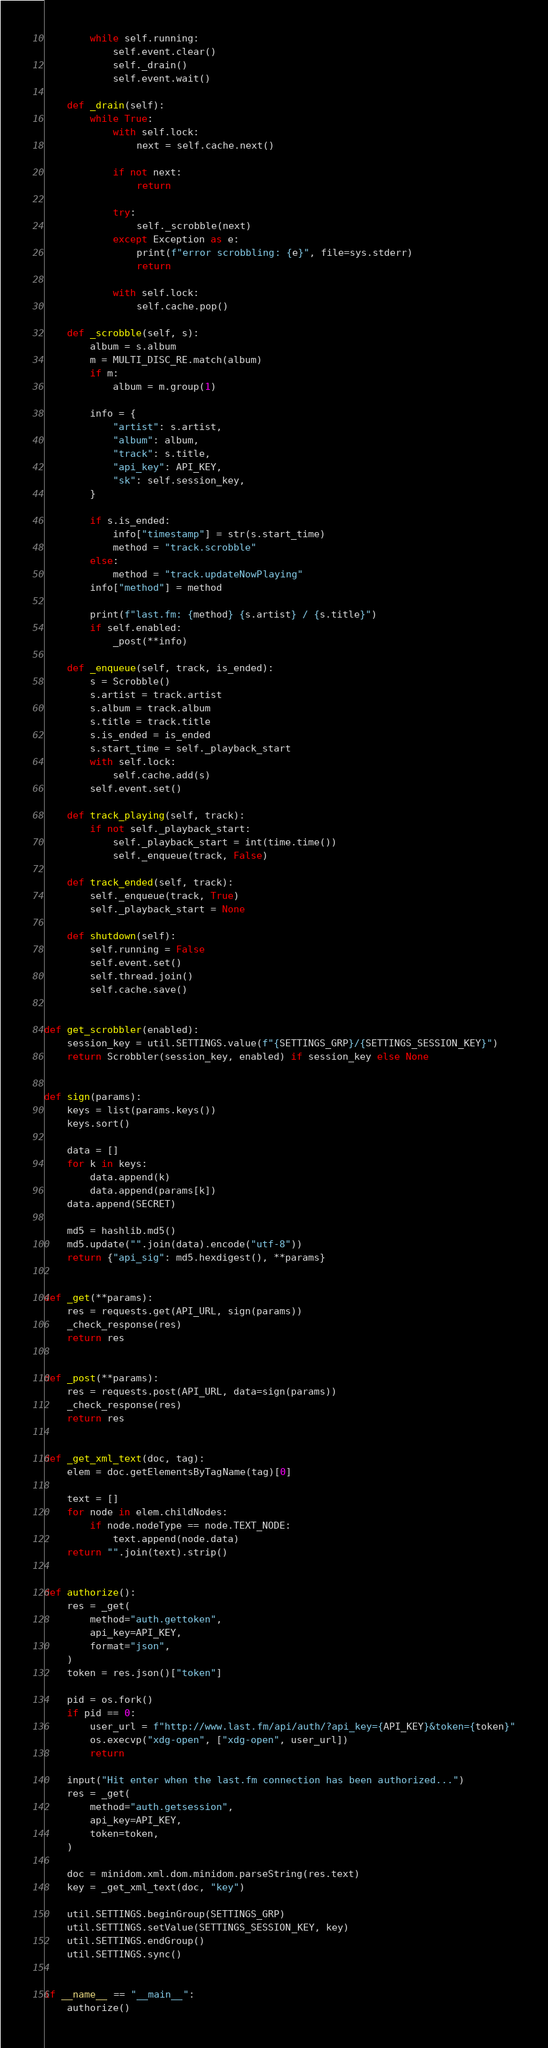<code> <loc_0><loc_0><loc_500><loc_500><_Python_>        while self.running:
            self.event.clear()
            self._drain()
            self.event.wait()

    def _drain(self):
        while True:
            with self.lock:
                next = self.cache.next()

            if not next:
                return

            try:
                self._scrobble(next)
            except Exception as e:
                print(f"error scrobbling: {e}", file=sys.stderr)
                return

            with self.lock:
                self.cache.pop()

    def _scrobble(self, s):
        album = s.album
        m = MULTI_DISC_RE.match(album)
        if m:
            album = m.group(1)

        info = {
            "artist": s.artist,
            "album": album,
            "track": s.title,
            "api_key": API_KEY,
            "sk": self.session_key,
        }

        if s.is_ended:
            info["timestamp"] = str(s.start_time)
            method = "track.scrobble"
        else:
            method = "track.updateNowPlaying"
        info["method"] = method

        print(f"last.fm: {method} {s.artist} / {s.title}")
        if self.enabled:
            _post(**info)

    def _enqueue(self, track, is_ended):
        s = Scrobble()
        s.artist = track.artist
        s.album = track.album
        s.title = track.title
        s.is_ended = is_ended
        s.start_time = self._playback_start
        with self.lock:
            self.cache.add(s)
        self.event.set()

    def track_playing(self, track):
        if not self._playback_start:
            self._playback_start = int(time.time())
            self._enqueue(track, False)

    def track_ended(self, track):
        self._enqueue(track, True)
        self._playback_start = None

    def shutdown(self):
        self.running = False
        self.event.set()
        self.thread.join()
        self.cache.save()


def get_scrobbler(enabled):
    session_key = util.SETTINGS.value(f"{SETTINGS_GRP}/{SETTINGS_SESSION_KEY}")
    return Scrobbler(session_key, enabled) if session_key else None


def sign(params):
    keys = list(params.keys())
    keys.sort()

    data = []
    for k in keys:
        data.append(k)
        data.append(params[k])
    data.append(SECRET)

    md5 = hashlib.md5()
    md5.update("".join(data).encode("utf-8"))
    return {"api_sig": md5.hexdigest(), **params}


def _get(**params):
    res = requests.get(API_URL, sign(params))
    _check_response(res)
    return res


def _post(**params):
    res = requests.post(API_URL, data=sign(params))
    _check_response(res)
    return res


def _get_xml_text(doc, tag):
    elem = doc.getElementsByTagName(tag)[0]

    text = []
    for node in elem.childNodes:
        if node.nodeType == node.TEXT_NODE:
            text.append(node.data)
    return "".join(text).strip()


def authorize():
    res = _get(
        method="auth.gettoken",
        api_key=API_KEY,
        format="json",
    )
    token = res.json()["token"]

    pid = os.fork()
    if pid == 0:
        user_url = f"http://www.last.fm/api/auth/?api_key={API_KEY}&token={token}"
        os.execvp("xdg-open", ["xdg-open", user_url])
        return

    input("Hit enter when the last.fm connection has been authorized...")
    res = _get(
        method="auth.getsession",
        api_key=API_KEY,
        token=token,
    )

    doc = minidom.xml.dom.minidom.parseString(res.text)
    key = _get_xml_text(doc, "key")

    util.SETTINGS.beginGroup(SETTINGS_GRP)
    util.SETTINGS.setValue(SETTINGS_SESSION_KEY, key)
    util.SETTINGS.endGroup()
    util.SETTINGS.sync()


if __name__ == "__main__":
    authorize()
</code> 